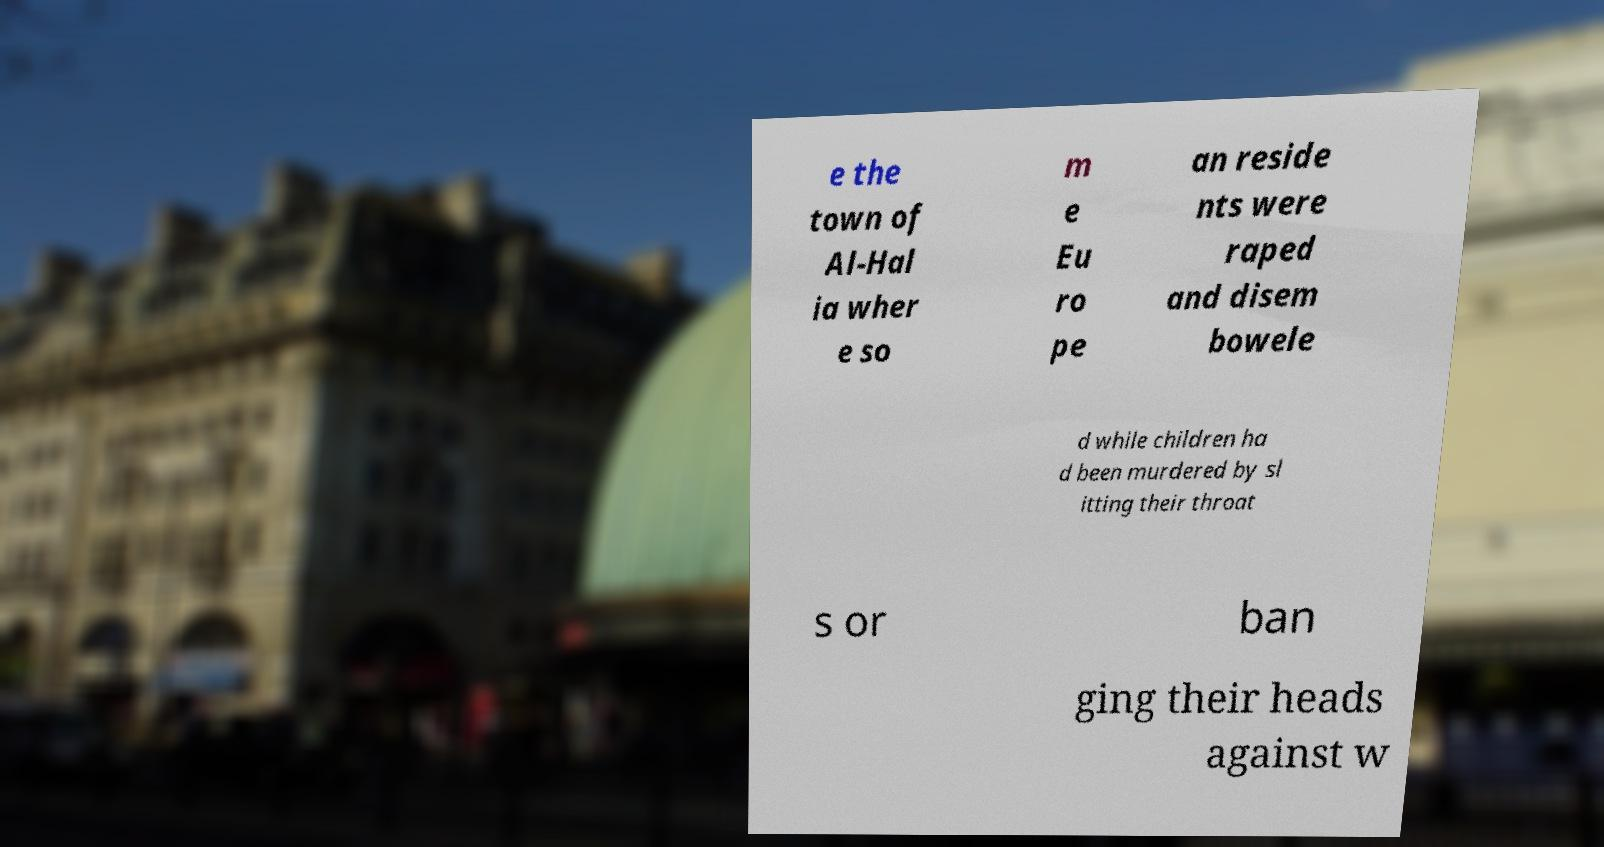Could you assist in decoding the text presented in this image and type it out clearly? e the town of Al-Hal ia wher e so m e Eu ro pe an reside nts were raped and disem bowele d while children ha d been murdered by sl itting their throat s or ban ging their heads against w 